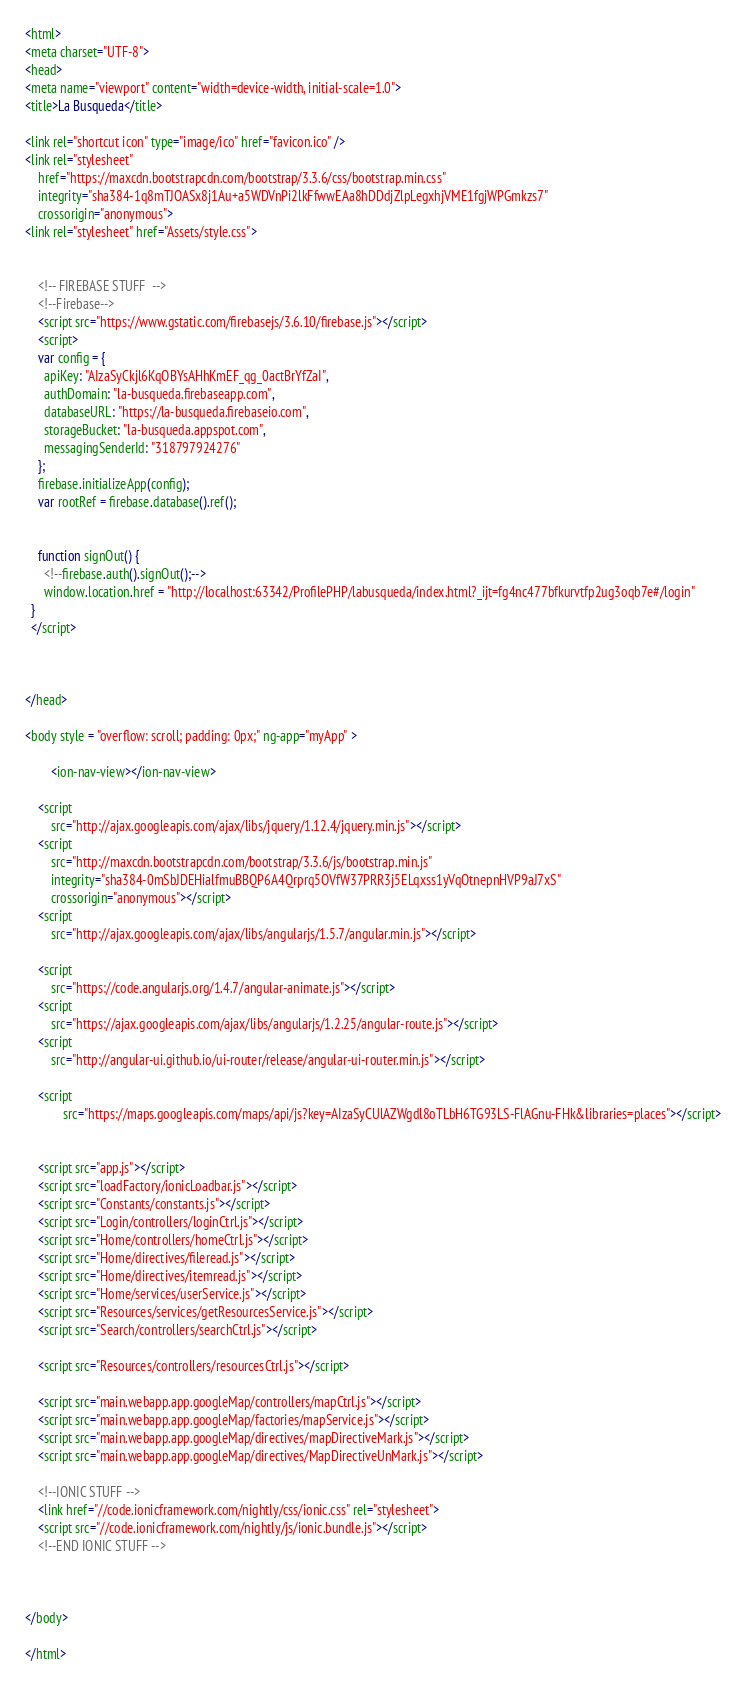<code> <loc_0><loc_0><loc_500><loc_500><_HTML_><html>
<meta charset="UTF-8">
<head>
<meta name="viewport" content="width=device-width, initial-scale=1.0">
<title>La Busqueda</title>

<link rel="shortcut icon" type="image/ico" href="favicon.ico" />
<link rel="stylesheet"
	href="https://maxcdn.bootstrapcdn.com/bootstrap/3.3.6/css/bootstrap.min.css"
	integrity="sha384-1q8mTJOASx8j1Au+a5WDVnPi2lkFfwwEAa8hDDdjZlpLegxhjVME1fgjWPGmkzs7"
	crossorigin="anonymous">
<link rel="stylesheet" href="Assets/style.css">


	<!-- FIREBASE STUFF  -->
	<!--Firebase-->
	<script src="https://www.gstatic.com/firebasejs/3.6.10/firebase.js"></script>
	<script>
    var config = {
      apiKey: "AIzaSyCkjl6KqOBYsAHhKmEF_qg_0actBrYfZaI",
      authDomain: "la-busqueda.firebaseapp.com",
      databaseURL: "https://la-busqueda.firebaseio.com",
      storageBucket: "la-busqueda.appspot.com",
      messagingSenderId: "318797924276"
    };
    firebase.initializeApp(config);
    var rootRef = firebase.database().ref();


	function signOut() {
      <!--firebase.auth().signOut();-->
      window.location.href = "http://localhost:63342/ProfilePHP/labusqueda/index.html?_ijt=fg4nc477bfkurvtfp2ug3oqb7e#/login"
  }
  </script>



</head>

<body style = "overflow: scroll; padding: 0px;" ng-app="myApp" >

		<ion-nav-view></ion-nav-view>

	<script
		src="http://ajax.googleapis.com/ajax/libs/jquery/1.12.4/jquery.min.js"></script>
	<script
		src="http://maxcdn.bootstrapcdn.com/bootstrap/3.3.6/js/bootstrap.min.js"
		integrity="sha384-0mSbJDEHialfmuBBQP6A4Qrprq5OVfW37PRR3j5ELqxss1yVqOtnepnHVP9aJ7xS"
		crossorigin="anonymous"></script>
	<script
		src="http://ajax.googleapis.com/ajax/libs/angularjs/1.5.7/angular.min.js"></script>

	<script
		src="https://code.angularjs.org/1.4.7/angular-animate.js"></script>
	<script
		src="https://ajax.googleapis.com/ajax/libs/angularjs/1.2.25/angular-route.js"></script>
	<script
		src="http://angular-ui.github.io/ui-router/release/angular-ui-router.min.js"></script>

	<script
			src="https://maps.googleapis.com/maps/api/js?key=AIzaSyCUlAZWgdl8oTLbH6TG93LS-FlAGnu-FHk&libraries=places"></script>


	<script src="app.js"></script>
	<script src="loadFactory/ionicLoadbar.js"></script>
	<script src="Constants/constants.js"></script>
	<script src="Login/controllers/loginCtrl.js"></script>
	<script src="Home/controllers/homeCtrl.js"></script>
	<script src="Home/directives/fileread.js"></script>
	<script src="Home/directives/itemread.js"></script>
	<script src="Home/services/userService.js"></script>
	<script src="Resources/services/getResourcesService.js"></script>
	<script src="Search/controllers/searchCtrl.js"></script>

	<script src="Resources/controllers/resourcesCtrl.js"></script>

	<script src="main.webapp.app.googleMap/controllers/mapCtrl.js"></script>
	<script src="main.webapp.app.googleMap/factories/mapService.js"></script>
	<script src="main.webapp.app.googleMap/directives/mapDirectiveMark.js"></script>
	<script src="main.webapp.app.googleMap/directives/MapDirectiveUnMark.js"></script>

	<!--IONIC STUFF -->
	<link href="//code.ionicframework.com/nightly/css/ionic.css" rel="stylesheet">
	<script src="//code.ionicframework.com/nightly/js/ionic.bundle.js"></script>
	<!--END IONIC STUFF -->



</body>

</html>
</code> 